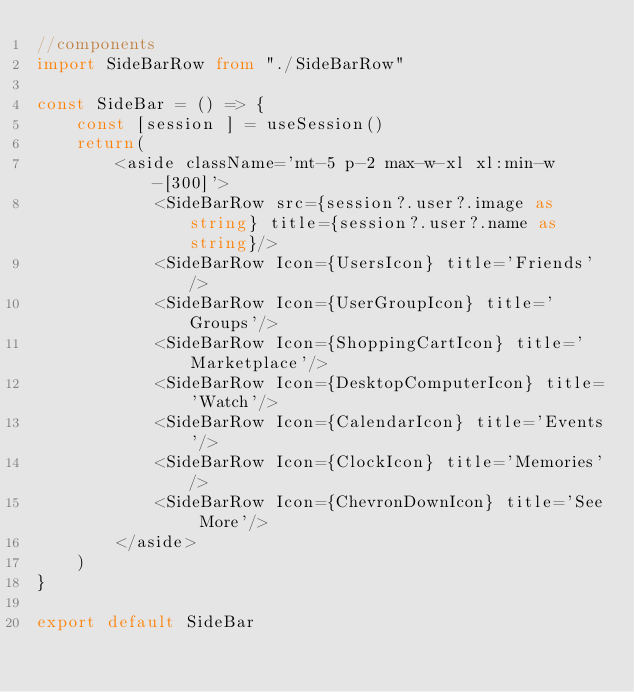<code> <loc_0><loc_0><loc_500><loc_500><_TypeScript_>//components
import SideBarRow from "./SideBarRow"

const SideBar = () => {
    const [session ] = useSession()
    return(
        <aside className='mt-5 p-2 max-w-xl xl:min-w-[300]'>
            <SideBarRow src={session?.user?.image as string} title={session?.user?.name as string}/>
            <SideBarRow Icon={UsersIcon} title='Friends'/>
            <SideBarRow Icon={UserGroupIcon} title='Groups'/>
            <SideBarRow Icon={ShoppingCartIcon} title='Marketplace'/>
            <SideBarRow Icon={DesktopComputerIcon} title='Watch'/>
            <SideBarRow Icon={CalendarIcon} title='Events'/>
            <SideBarRow Icon={ClockIcon} title='Memories'/>
            <SideBarRow Icon={ChevronDownIcon} title='See More'/>
        </aside>
    )
}

export default SideBar 
</code> 